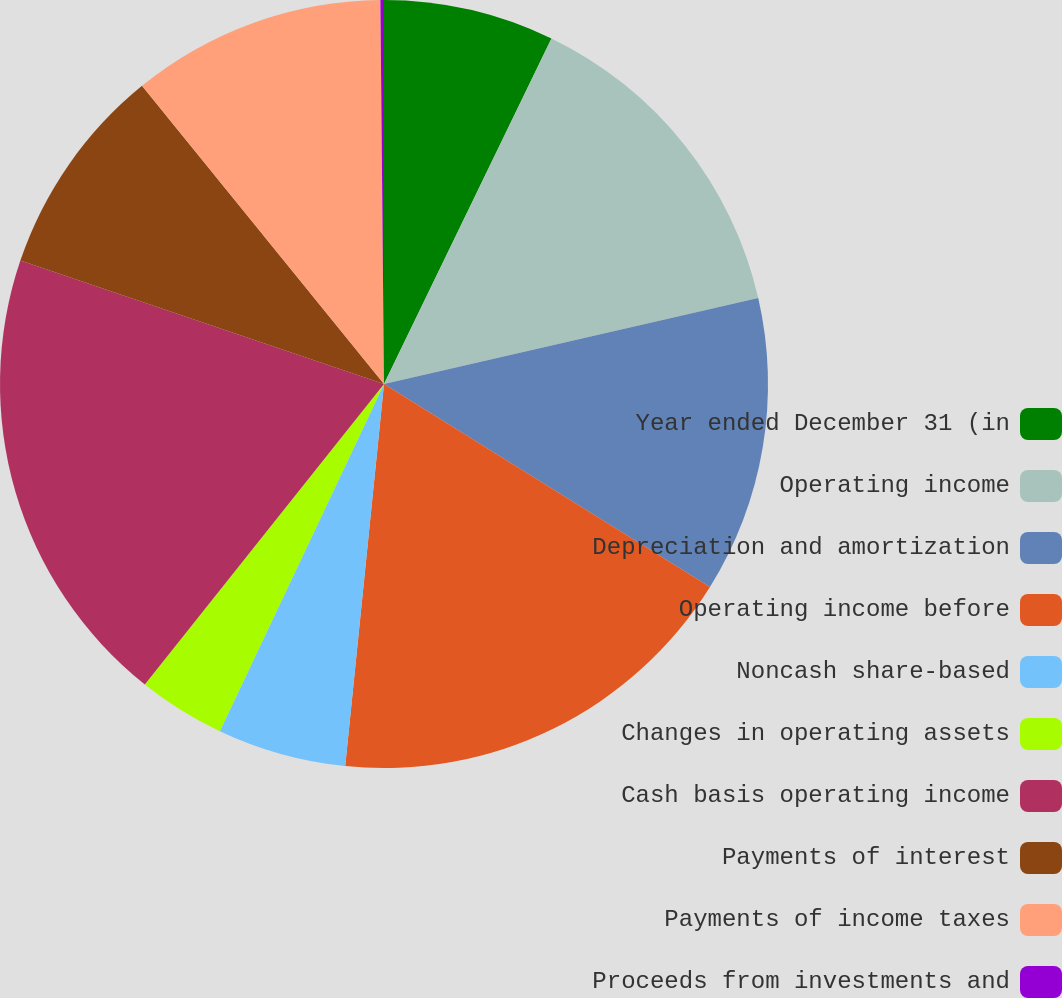<chart> <loc_0><loc_0><loc_500><loc_500><pie_chart><fcel>Year ended December 31 (in<fcel>Operating income<fcel>Depreciation and amortization<fcel>Operating income before<fcel>Noncash share-based<fcel>Changes in operating assets<fcel>Cash basis operating income<fcel>Payments of interest<fcel>Payments of income taxes<fcel>Proceeds from investments and<nl><fcel>7.18%<fcel>14.22%<fcel>12.46%<fcel>17.74%<fcel>5.42%<fcel>3.67%<fcel>19.5%<fcel>8.94%<fcel>10.7%<fcel>0.15%<nl></chart> 